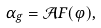Convert formula to latex. <formula><loc_0><loc_0><loc_500><loc_500>\alpha _ { g } = \mathcal { A } F ( \varphi ) ,</formula> 